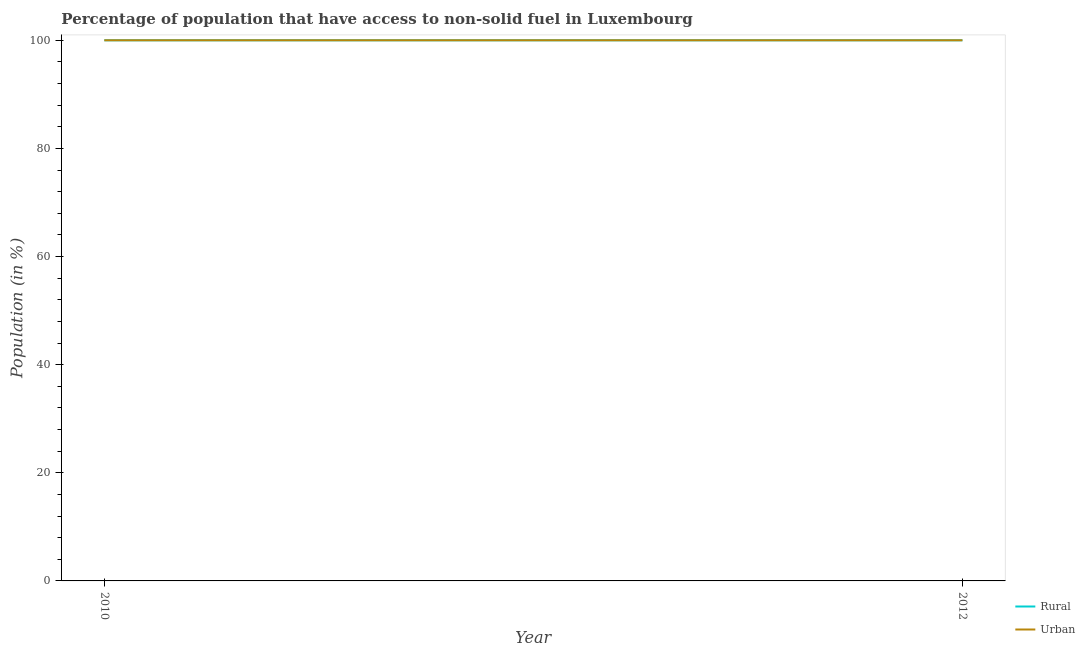How many different coloured lines are there?
Keep it short and to the point. 2. Does the line corresponding to urban population intersect with the line corresponding to rural population?
Offer a very short reply. Yes. Is the number of lines equal to the number of legend labels?
Your response must be concise. Yes. What is the rural population in 2010?
Your answer should be very brief. 100. Across all years, what is the maximum urban population?
Offer a terse response. 100. Across all years, what is the minimum rural population?
Offer a very short reply. 100. In which year was the urban population maximum?
Keep it short and to the point. 2010. What is the total urban population in the graph?
Ensure brevity in your answer.  200. What is the difference between the rural population in 2010 and that in 2012?
Make the answer very short. 0. In the year 2010, what is the difference between the rural population and urban population?
Provide a succinct answer. 0. In how many years, is the urban population greater than 8 %?
Give a very brief answer. 2. What is the ratio of the rural population in 2010 to that in 2012?
Ensure brevity in your answer.  1. Is the rural population in 2010 less than that in 2012?
Give a very brief answer. No. In how many years, is the rural population greater than the average rural population taken over all years?
Provide a succinct answer. 0. Does the urban population monotonically increase over the years?
Offer a terse response. No. Is the urban population strictly greater than the rural population over the years?
Your response must be concise. No. Is the rural population strictly less than the urban population over the years?
Your answer should be compact. No. How many lines are there?
Make the answer very short. 2. What is the difference between two consecutive major ticks on the Y-axis?
Ensure brevity in your answer.  20. Does the graph contain any zero values?
Ensure brevity in your answer.  No. How are the legend labels stacked?
Offer a very short reply. Vertical. What is the title of the graph?
Provide a short and direct response. Percentage of population that have access to non-solid fuel in Luxembourg. Does "Short-term debt" appear as one of the legend labels in the graph?
Offer a terse response. No. What is the label or title of the X-axis?
Provide a succinct answer. Year. What is the label or title of the Y-axis?
Make the answer very short. Population (in %). What is the Population (in %) of Rural in 2010?
Offer a terse response. 100. What is the Population (in %) in Urban in 2012?
Make the answer very short. 100. Across all years, what is the maximum Population (in %) in Rural?
Give a very brief answer. 100. Across all years, what is the maximum Population (in %) in Urban?
Ensure brevity in your answer.  100. Across all years, what is the minimum Population (in %) in Rural?
Make the answer very short. 100. Across all years, what is the minimum Population (in %) in Urban?
Give a very brief answer. 100. What is the difference between the Population (in %) in Rural in 2010 and the Population (in %) in Urban in 2012?
Your answer should be very brief. 0. What is the average Population (in %) of Urban per year?
Give a very brief answer. 100. In the year 2010, what is the difference between the Population (in %) in Rural and Population (in %) in Urban?
Ensure brevity in your answer.  0. In the year 2012, what is the difference between the Population (in %) of Rural and Population (in %) of Urban?
Keep it short and to the point. 0. What is the ratio of the Population (in %) in Rural in 2010 to that in 2012?
Your response must be concise. 1. What is the ratio of the Population (in %) in Urban in 2010 to that in 2012?
Ensure brevity in your answer.  1. 